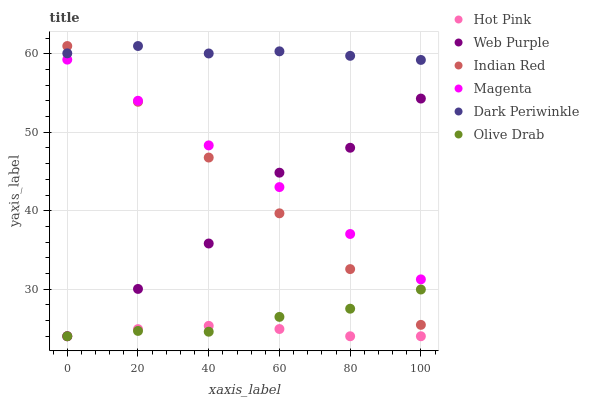Does Hot Pink have the minimum area under the curve?
Answer yes or no. Yes. Does Dark Periwinkle have the maximum area under the curve?
Answer yes or no. Yes. Does Web Purple have the minimum area under the curve?
Answer yes or no. No. Does Web Purple have the maximum area under the curve?
Answer yes or no. No. Is Indian Red the smoothest?
Answer yes or no. Yes. Is Web Purple the roughest?
Answer yes or no. Yes. Is Web Purple the smoothest?
Answer yes or no. No. Is Indian Red the roughest?
Answer yes or no. No. Does Hot Pink have the lowest value?
Answer yes or no. Yes. Does Indian Red have the lowest value?
Answer yes or no. No. Does Dark Periwinkle have the highest value?
Answer yes or no. Yes. Does Web Purple have the highest value?
Answer yes or no. No. Is Web Purple less than Dark Periwinkle?
Answer yes or no. Yes. Is Dark Periwinkle greater than Hot Pink?
Answer yes or no. Yes. Does Olive Drab intersect Web Purple?
Answer yes or no. Yes. Is Olive Drab less than Web Purple?
Answer yes or no. No. Is Olive Drab greater than Web Purple?
Answer yes or no. No. Does Web Purple intersect Dark Periwinkle?
Answer yes or no. No. 